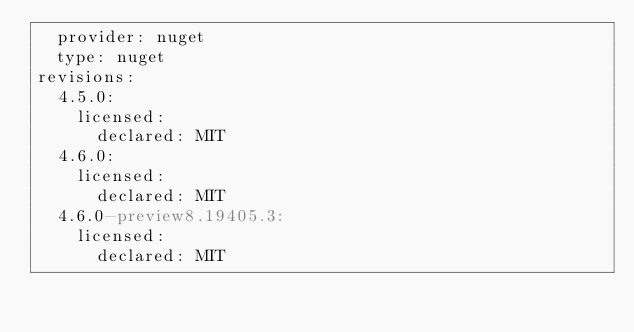Convert code to text. <code><loc_0><loc_0><loc_500><loc_500><_YAML_>  provider: nuget
  type: nuget
revisions:
  4.5.0:
    licensed:
      declared: MIT
  4.6.0:
    licensed:
      declared: MIT
  4.6.0-preview8.19405.3:
    licensed:
      declared: MIT
</code> 